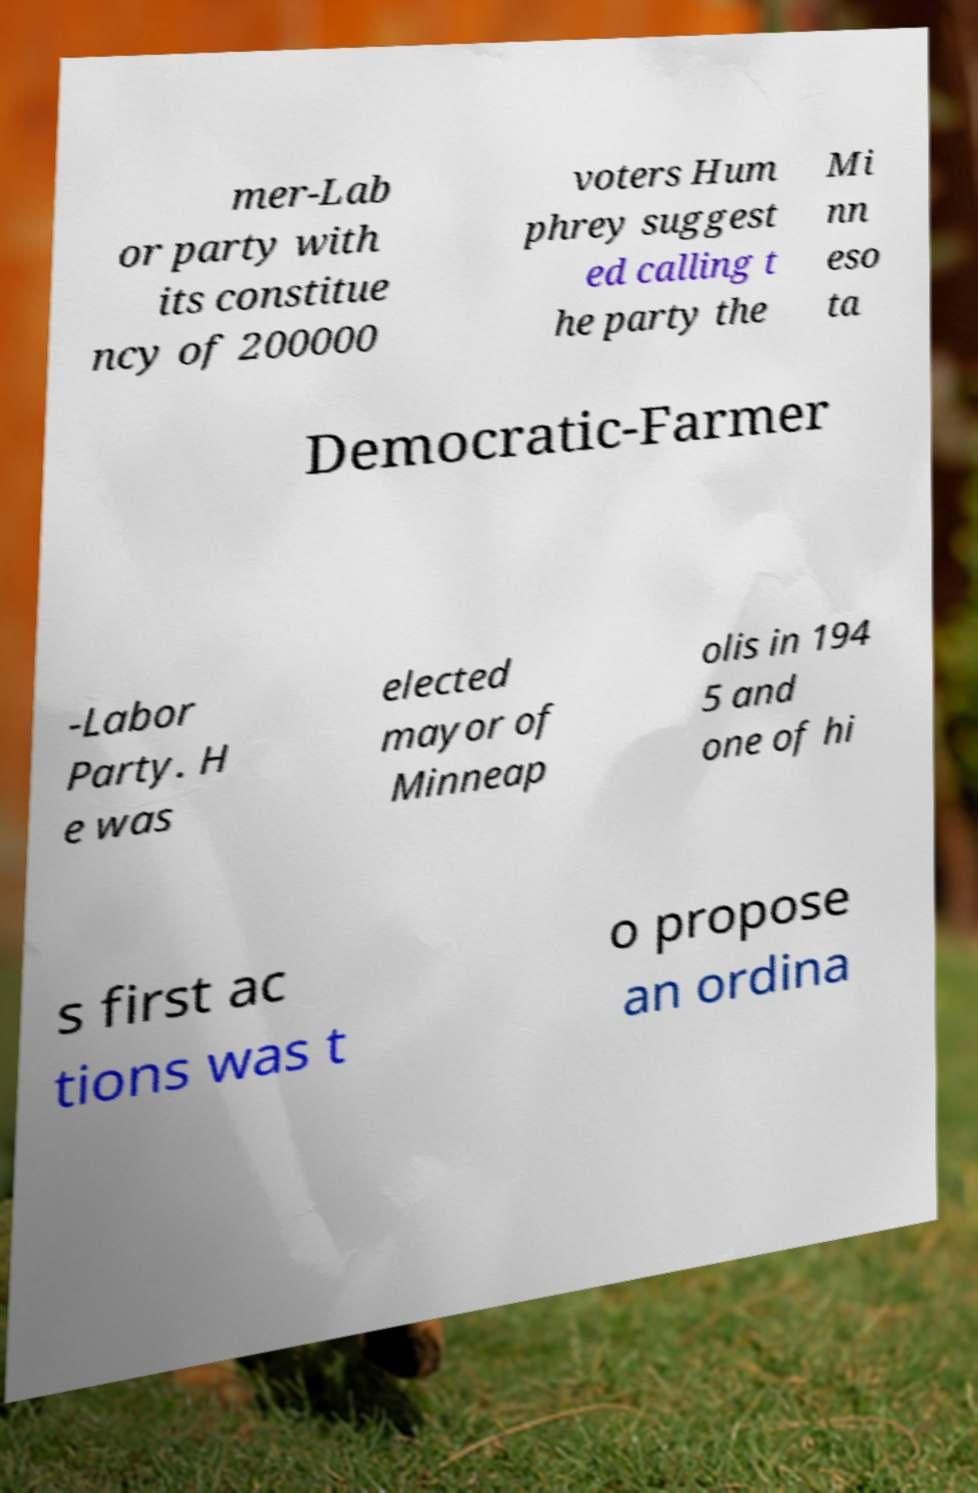I need the written content from this picture converted into text. Can you do that? mer-Lab or party with its constitue ncy of 200000 voters Hum phrey suggest ed calling t he party the Mi nn eso ta Democratic-Farmer -Labor Party. H e was elected mayor of Minneap olis in 194 5 and one of hi s first ac tions was t o propose an ordina 